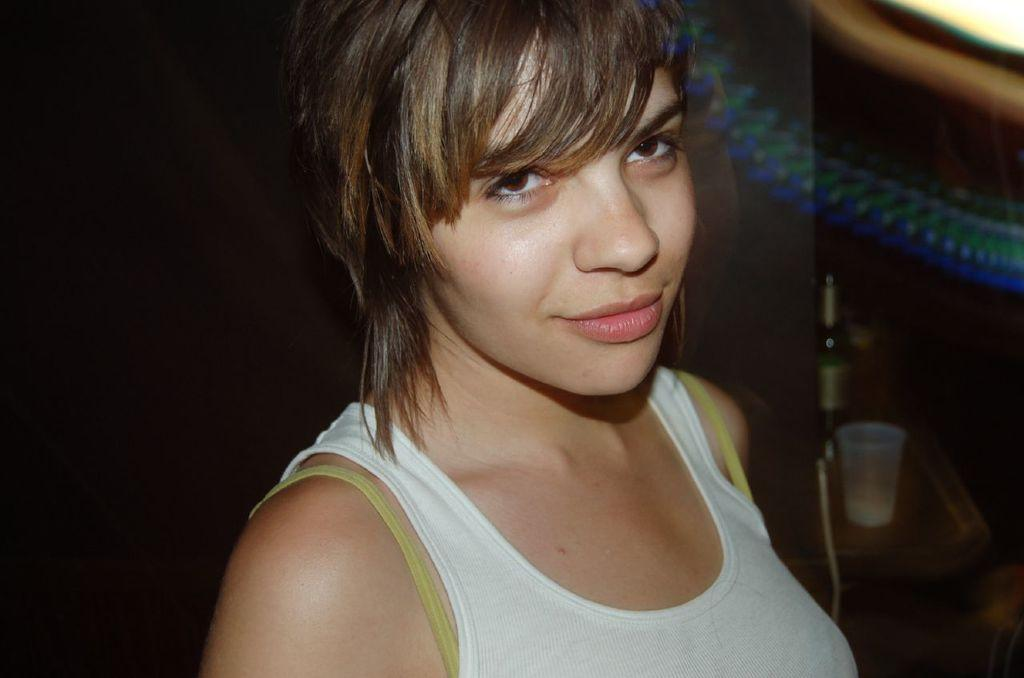Who is the main subject in the image? There is a girl in the image. What is the girl wearing? The girl is wearing a white T-shirt. How would you describe the lighting on the left side of the image? The left side of the image is dark. What can be seen on the right side of the image? There is a table on the right side of the image. What items are on the table? There is a bottle and a glass on the table. Is the girl putting the baby in the crib in the image? There is no crib present in the image, and the girl is not shown interacting with a baby. What type of drink is the girl holding in the image? The image does not show the girl holding any drink; she is simply wearing a white T-shirt. 